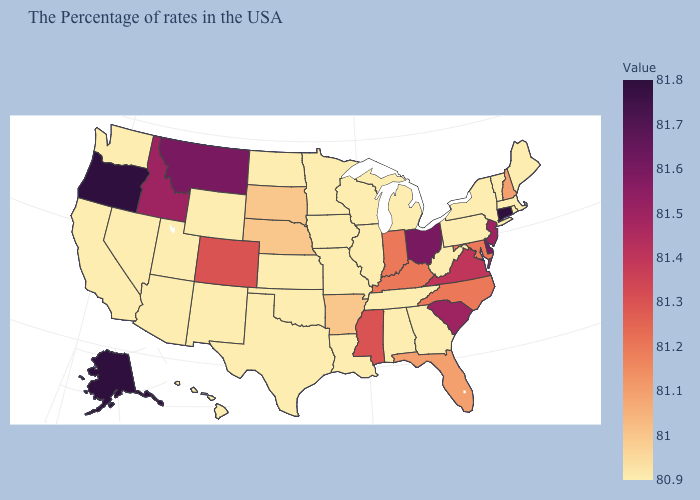Among the states that border Oklahoma , which have the highest value?
Give a very brief answer. Colorado. Which states have the lowest value in the West?
Quick response, please. Wyoming, New Mexico, Utah, Arizona, Nevada, California, Washington, Hawaii. Among the states that border Idaho , does Wyoming have the lowest value?
Concise answer only. Yes. Is the legend a continuous bar?
Answer briefly. Yes. Is the legend a continuous bar?
Concise answer only. Yes. 